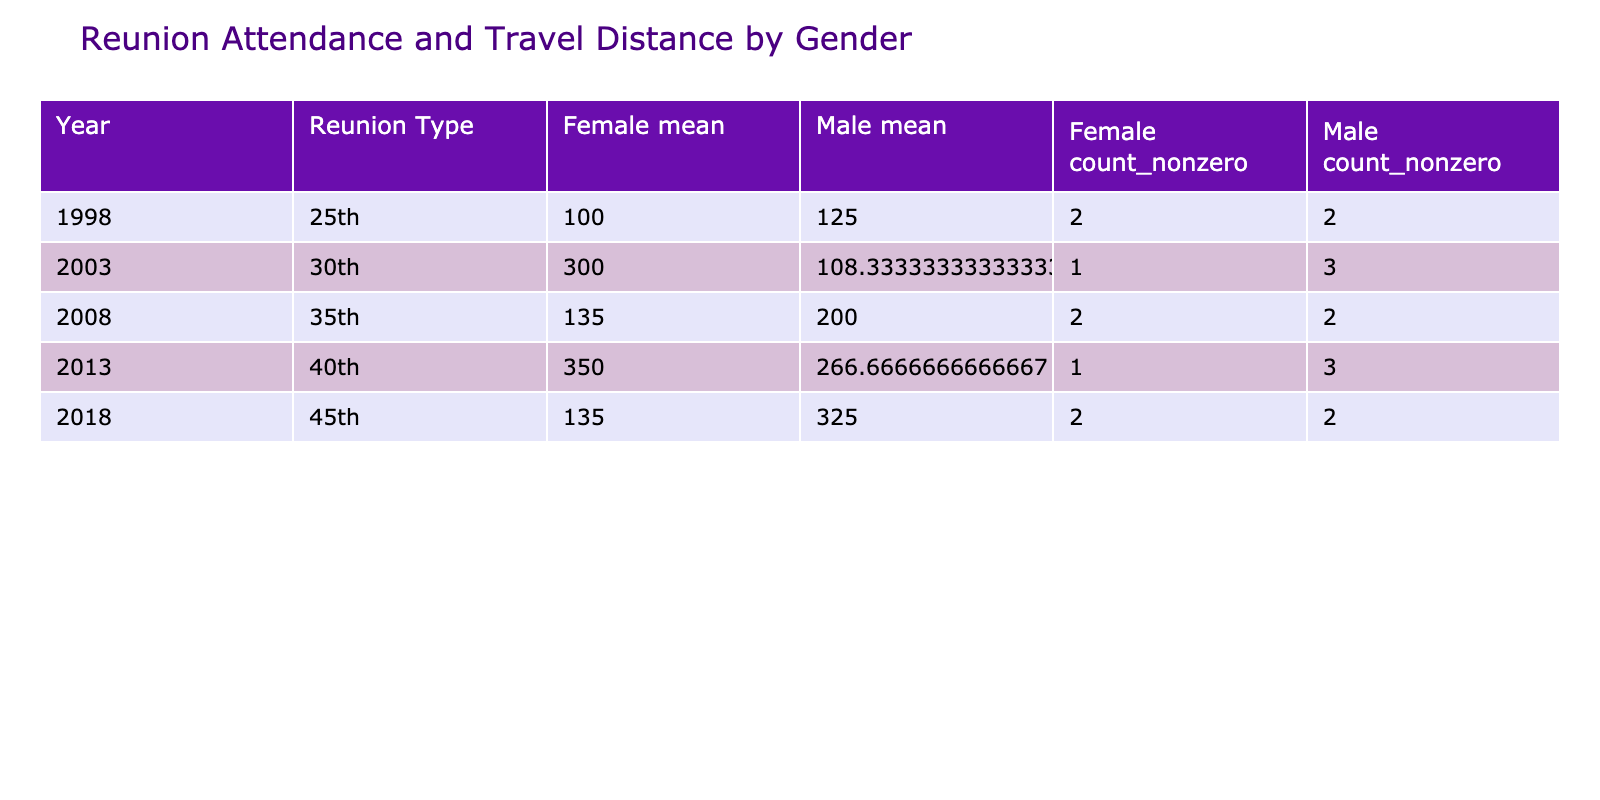What was the total distance traveled by male attendees in 2013? In 2013, the male attendees were Lyle Norman Long (200), William Taylor (100), and Richard Lee (500). To find the total distance traveled by males, add these distances: 200 + 100 + 500 = 800.
Answer: 800 What is the average distance traveled by female attendees in 2003? The only female attendee in 2003 was Jennifer White, who traveled a distance of 300. Since there is only one data point, the average distance is 300 / 1 = 300.
Answer: 300 Did more male or female attendees participate in the 35th reunion in 2008? In 2008, there were two male attendees (Lyle Norman Long and Thomas Wilson) and two female attendees (Patricia Miller and Linda Anderson). Since the number of male attendees (2) equals the number of female attendees (2), the answer is a tie.
Answer: No What was the difference in distance traveled by female attendees between the 25th and 40th reunions? For the 25th reunion in 1998, Emily Clark’s distance was 80. In the 40th reunion in 2013, the only female attendee was Karen Martinez, who traveled 350. The difference in distance is 350 - 80 = 270.
Answer: 270 What percentage of total attendees in 2018 were female? The attendees in 2018 were Lyle Norman Long, Susan Harris, James Robinson, and Nancy Turner (total of 4). Out of these, 2 were female (Susan Harris and Nancy Turner). The percentage of female attendees is (2 / 4) * 100 = 50%.
Answer: 50% How many attendees traveled more than 200 miles in total for the 30th reunion in 2003? In 2003, the attendees were Lyle Norman Long (100), Robert Davis (150), Jennifer White (300), and David Brown (75). Only Jennifer White traveled more than 200 miles. Therefore, there was 1 attendee who traveled more than 200 miles.
Answer: 1 What is the total count of attendees at the 45th reunion in 2018? The attendees at the 45th reunion in 2018 were Lyle Norman Long, Susan Harris, James Robinson, and Nancy Turner. Counting these shows there are a total of 4 attendees.
Answer: 4 Which reunion had the highest average distance traveled by male attendees? To find this, consider the distance traveled by male attendees in each reunion. In 1998 males traveled: Lyle Norman Long (50), Michael Thompson (200), and David Brown (75) giving a total of 325 over 3 attendees, average = 325 / 3 = 108.33. For 2003: Lyle Norman Long (100), Robert Davis (150), and David Brown (75) giving a total of 325 over 3 attendees, average = 325 / 3 = 108.33. For 2008: Lyle Norman Long (150), Thomas Wilson (250) giving a total of 400 over 2 attendees, average = 400 / 2 = 200. For 2013: Lyle Norman Long (200), William Taylor (100), Richard Lee (500) totaling 800 over 3 gives an average of 800 / 3 = 266.67. For 2018: Lyle Norman Long (250), James Robinson (400) give a total of 650 across 2 attendees, average = 650 / 2 = 325. The highest average is in 2018 at 325.
Answer: 2018 